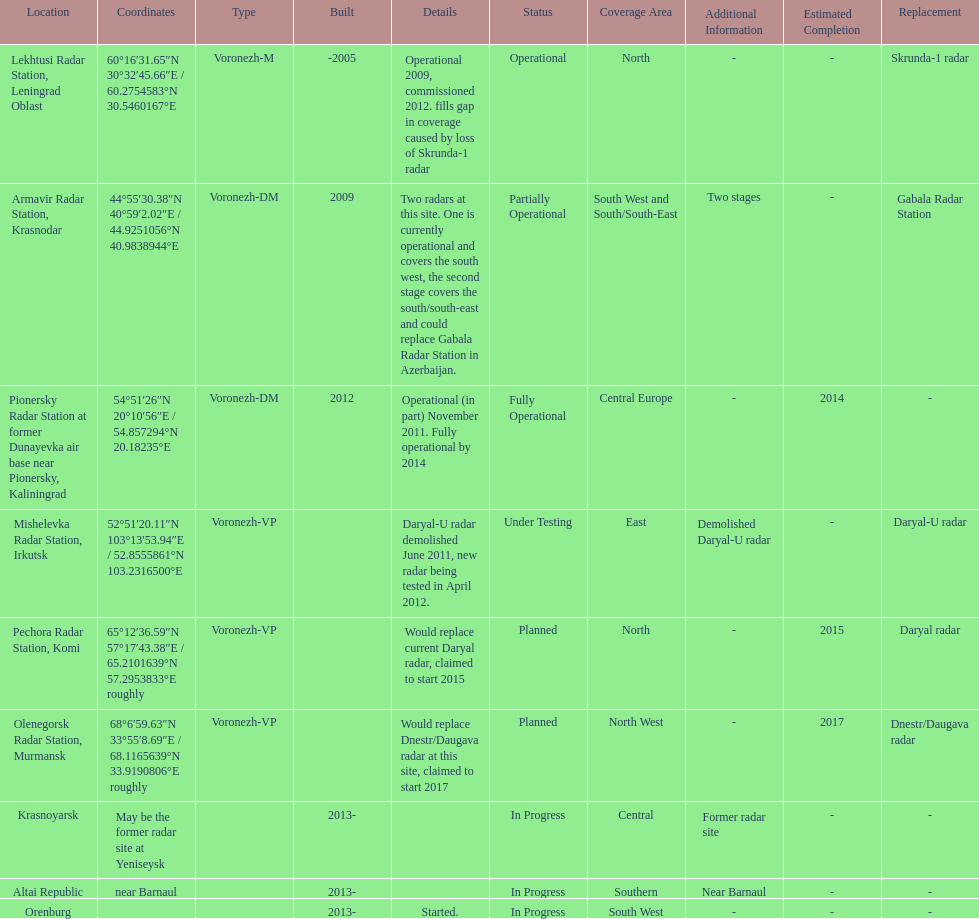What are the list of radar locations? Lekhtusi Radar Station, Leningrad Oblast, Armavir Radar Station, Krasnodar, Pionersky Radar Station at former Dunayevka air base near Pionersky, Kaliningrad, Mishelevka Radar Station, Irkutsk, Pechora Radar Station, Komi, Olenegorsk Radar Station, Murmansk, Krasnoyarsk, Altai Republic, Orenburg. Which of these are claimed to start in 2015? Pechora Radar Station, Komi. 